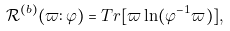<formula> <loc_0><loc_0><loc_500><loc_500>\mathcal { R } ^ { ( b ) } ( \varpi \colon \varphi ) = T r [ \varpi \ln ( \varphi ^ { - 1 } \varpi ) ] ,</formula> 